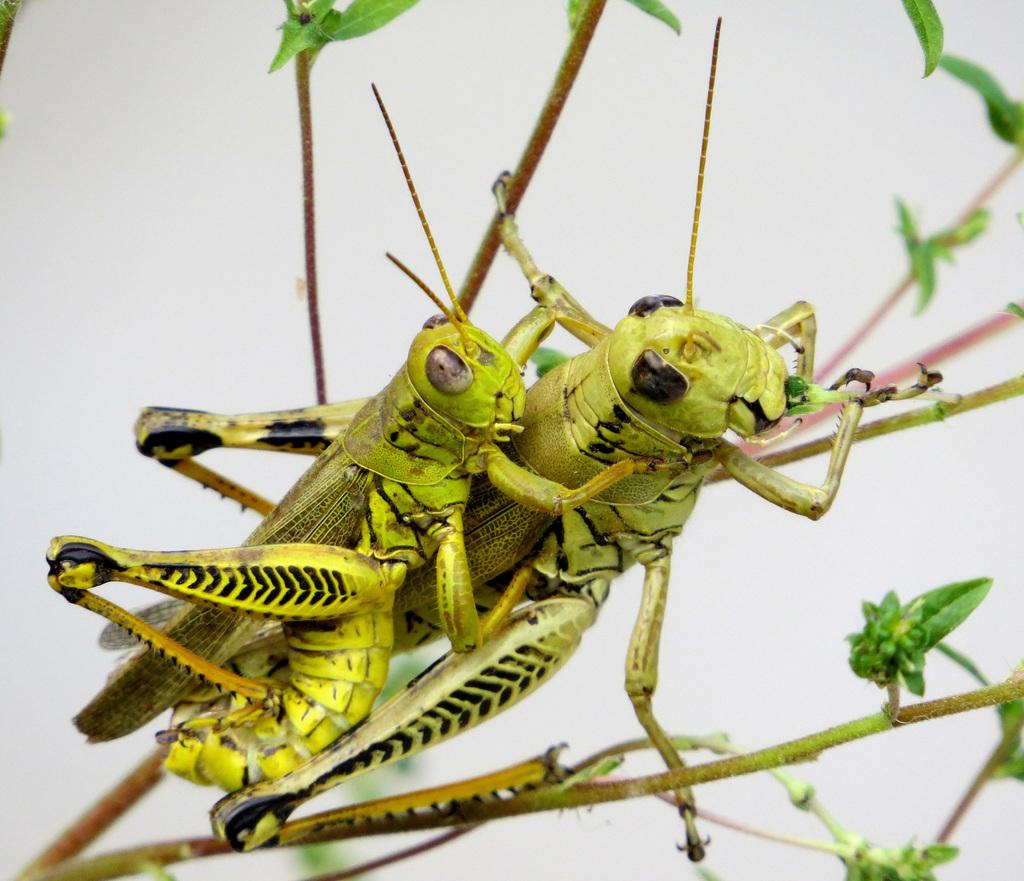What is present on the plant in the image? There are two insects on a plant in the image. What color is the background of the image? The background of the image is white. Can you determine the time of day the image was taken? The image was likely taken during the day, as there is sufficient light to see the insects and plant clearly. Where is the nest of the insects in the image? There is no nest visible in the image; only the two insects on the plant are present. Is there a fan in the image? There is no fan present in the image. 